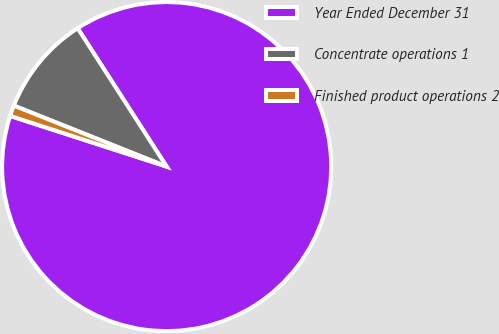Convert chart. <chart><loc_0><loc_0><loc_500><loc_500><pie_chart><fcel>Year Ended December 31<fcel>Concentrate operations 1<fcel>Finished product operations 2<nl><fcel>89.08%<fcel>9.86%<fcel>1.06%<nl></chart> 